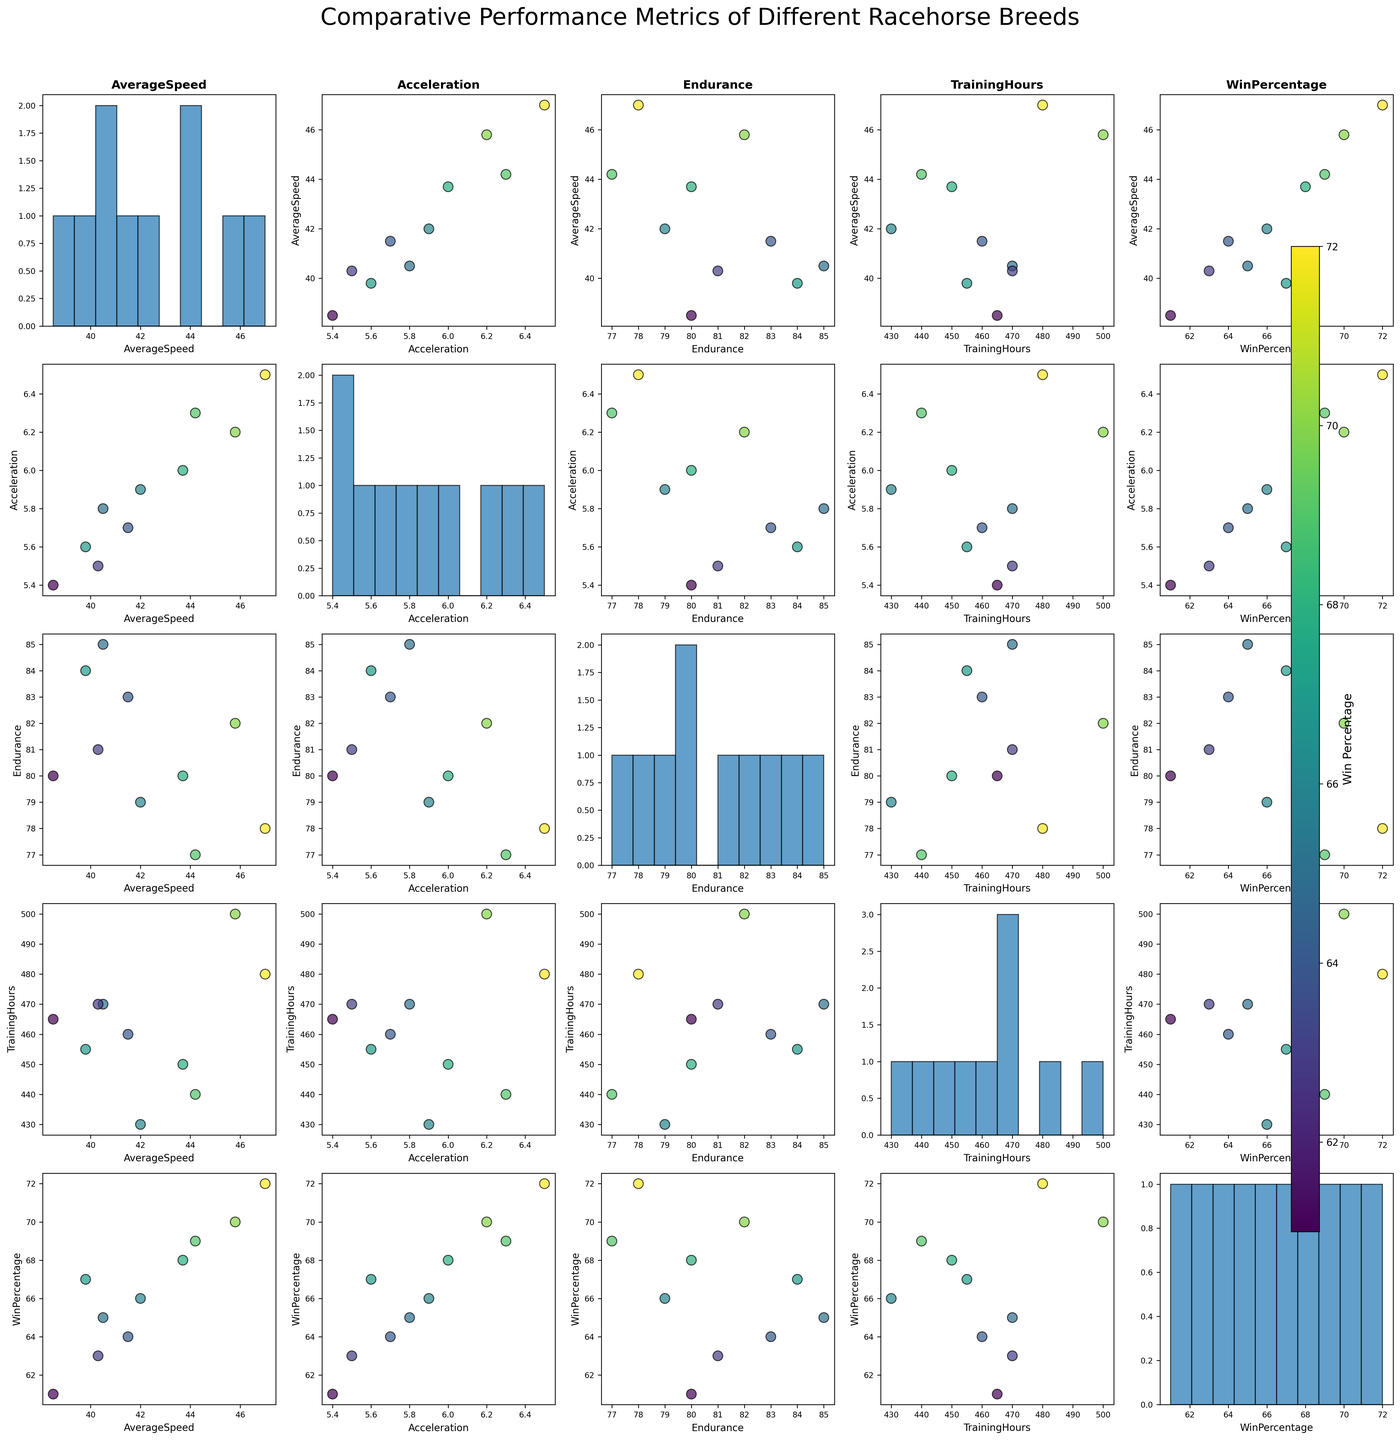Which breed has the highest average speed? By looking at the scatter plots or the histograms along the diagonal for the AverageSpeed metric, we can identify the breed with the highest average speed. Quarter Horse has the highest value.
Answer: Quarter Horse What is the relationship between acceleration and average speed among the different breeds? By observing the scatter plot where acceleration is on the x-axis and average speed is on the y-axis, one might notice that in general, those racehorses with higher accelerations tend to have higher average speeds.
Answer: Positive correlation Which breed has a higher win percentage: Thoroughbred or Arabian? Referring to the breed points in the scatter plots colored by win percentage or the legend for both Thoroughbred and Arabian, we find that Thoroughbred has a win percentage of 70 while Arabian has 65.
Answer: Thoroughbred Is there any apparent correlation between endurance and training hours? Reviewing the scatter plot with endurance on the y-axis and training hours on the x-axis, one can look for a trend or pattern. There doesn't appear to be a strong trend, hence no strong correlation.
Answer: No strong correlation Do breeds with higher win percentages generally have higher average speeds? Investigating the scatter plots with average speed against win percentage, we can see if there is any upward trend indicating higher speeds with higher win percentages. There seems to be a trend where breeds with higher average speeds also have higher win percentages.
Answer: Yes Which two breeds have the most similar combination of training hours and acceleration? Checking the scatter plot between training hours and acceleration, we look for points (breeds) that are close together. Thoroughbred (500, 6.2) and Paint Horse (440, 6.3) have similar close combinations.
Answer: Thoroughbred and Paint Horse Among the listed breeds, which one had the highest number of training hours? Using the histogram plot for TrainingHours, we identify the breed associated with the highest bin. The Thoroughbred breed is associated with 500 hours of training.
Answer: Thoroughbred Considering win percentage as an indicator, which breed performed the poorest? Observing the color bar and the scatter plots colored by win percentage, the breed with the dullest (darkest) shade reveals Friesian with the lowest win percentage of 61.
Answer: Friesian Is there a breed that combines above-average endurance with average speed of below 40? Checking scatter plots with endurance on the y-axis and average speed on the x-axis, breeds with endurance above ~81.5 (computed average) and average speed below 40 are scrutinized. Andalusian (84, 39.8) fits this criterion.
Answer: Andalusian 